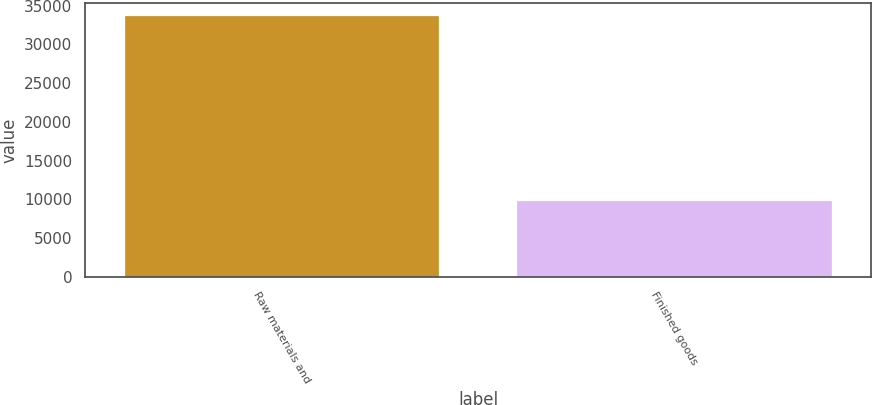<chart> <loc_0><loc_0><loc_500><loc_500><bar_chart><fcel>Raw materials and<fcel>Finished goods<nl><fcel>33596<fcel>9830<nl></chart> 